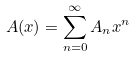<formula> <loc_0><loc_0><loc_500><loc_500>A ( x ) = \sum _ { n = 0 } ^ { \infty } A _ { n } x ^ { n }</formula> 